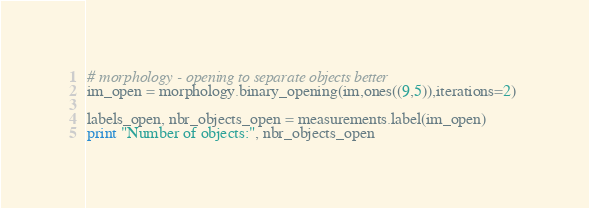<code> <loc_0><loc_0><loc_500><loc_500><_Python_>
# morphology - opening to separate objects better
im_open = morphology.binary_opening(im,ones((9,5)),iterations=2) 

labels_open, nbr_objects_open = measurements.label(im_open)
print "Number of objects:", nbr_objects_open</code> 